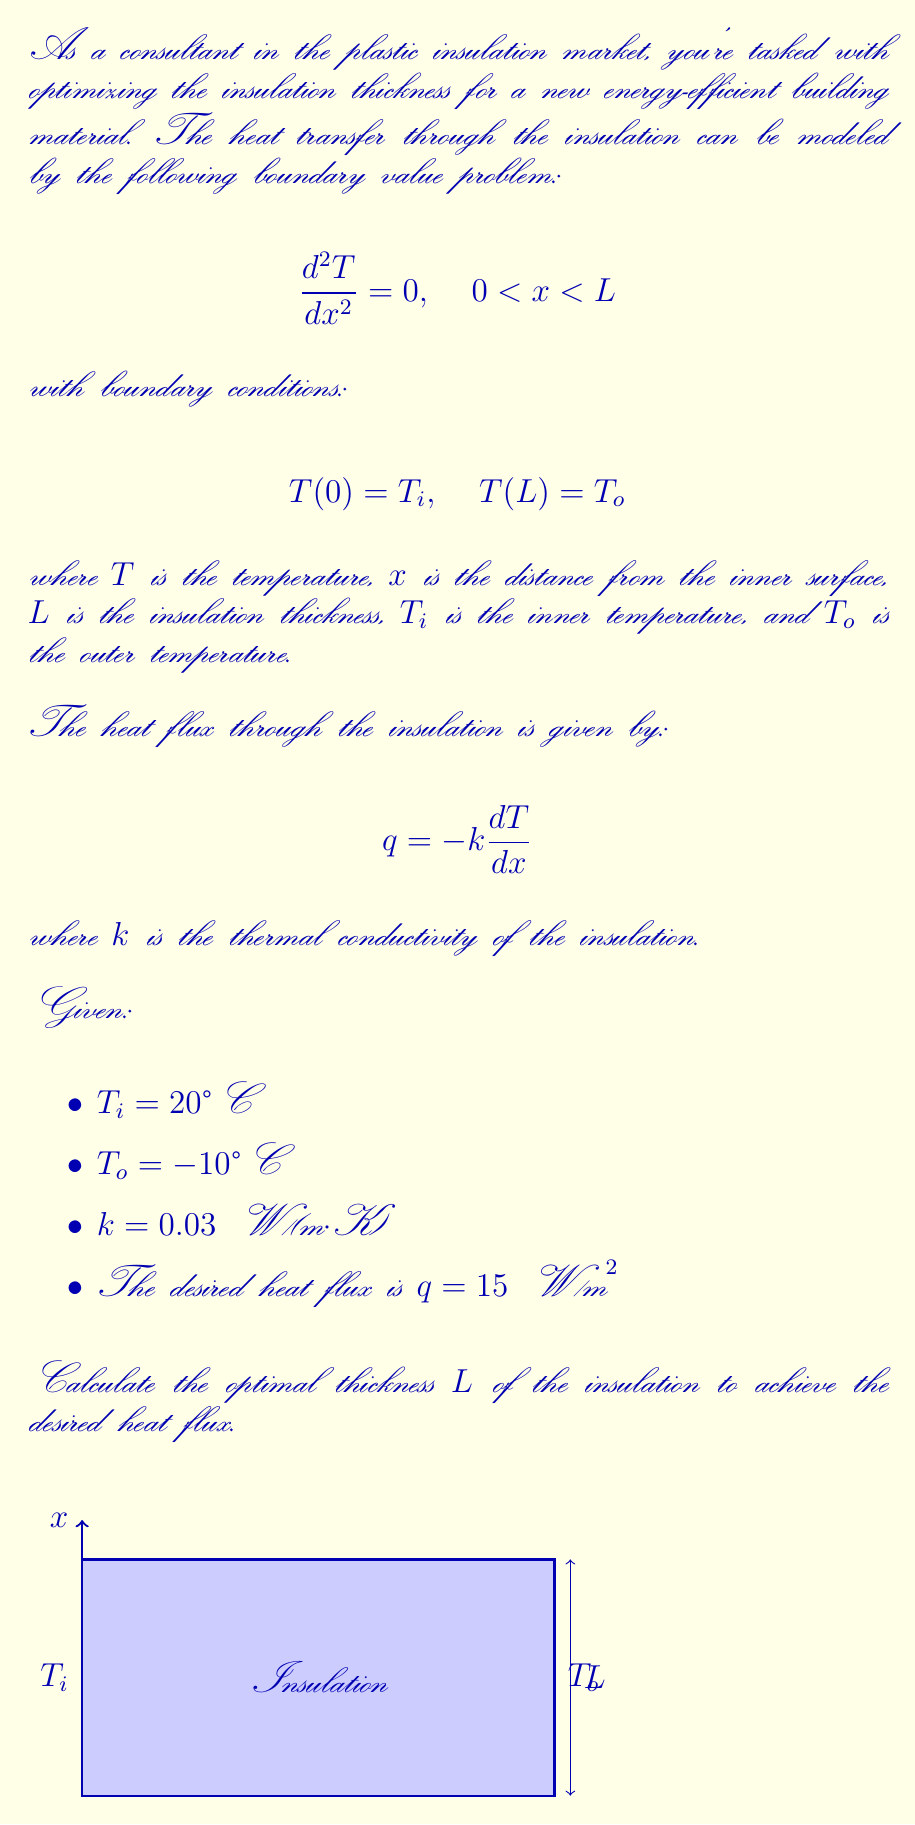What is the answer to this math problem? Let's solve this problem step by step:

1) The general solution to the differential equation $\frac{d^2T}{dx^2} = 0$ is:

   $$T(x) = ax + b$$

   where $a$ and $b$ are constants to be determined.

2) Apply the boundary conditions:
   
   At $x = 0$: $T(0) = T_i = b = 20°C$
   At $x = L$: $T(L) = T_o = aL + 20 = -10°C$

3) From the second condition:

   $$a = \frac{T_o - T_i}{L} = \frac{-10 - 20}{L} = -\frac{30}{L}$$

4) The temperature distribution is thus:

   $$T(x) = -\frac{30}{L}x + 20$$

5) The heat flux is given by:

   $$q = -k\frac{dT}{dx} = -k(-\frac{30}{L}) = \frac{30k}{L}$$

6) We're given that $q = 15 \text{ W/m}^2$ and $k = 0.03 \text{ W/(m·K)}$. Substituting these:

   $$15 = \frac{30 \cdot 0.03}{L}$$

7) Solving for $L$:

   $$L = \frac{30 \cdot 0.03}{15} = 0.06 \text{ m}$$

Therefore, the optimal thickness of the insulation is 0.06 meters or 6 centimeters.
Answer: $L = 0.06 \text{ m}$ 